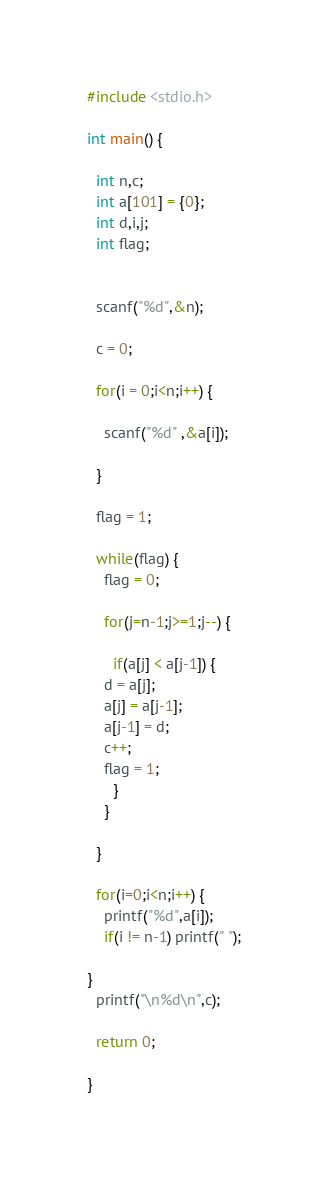<code> <loc_0><loc_0><loc_500><loc_500><_C_>#include <stdio.h>
 
int main() {
 
  int n,c;
  int a[101] = {0};
  int d,i,j;
  int flag;
 
 
  scanf("%d",&n);
 
  c = 0;
 
  for(i = 0;i<n;i++) {
 
    scanf("%d" ,&a[i]);
 
  }
 
  flag = 1;
 
  while(flag) { 
    flag = 0;
 
    for(j=n-1;j>=1;j--) {
       
      if(a[j] < a[j-1]) {
    d = a[j];
    a[j] = a[j-1];
    a[j-1] = d;
    c++;
    flag = 1;
      } 
    }
     
  }
 
  for(i=0;i<n;i++) {
    printf("%d",a[i]);
    if(i != n-1) printf(" ");
 
}
  printf("\n%d\n",c);
 
  return 0;
 
}
</code> 